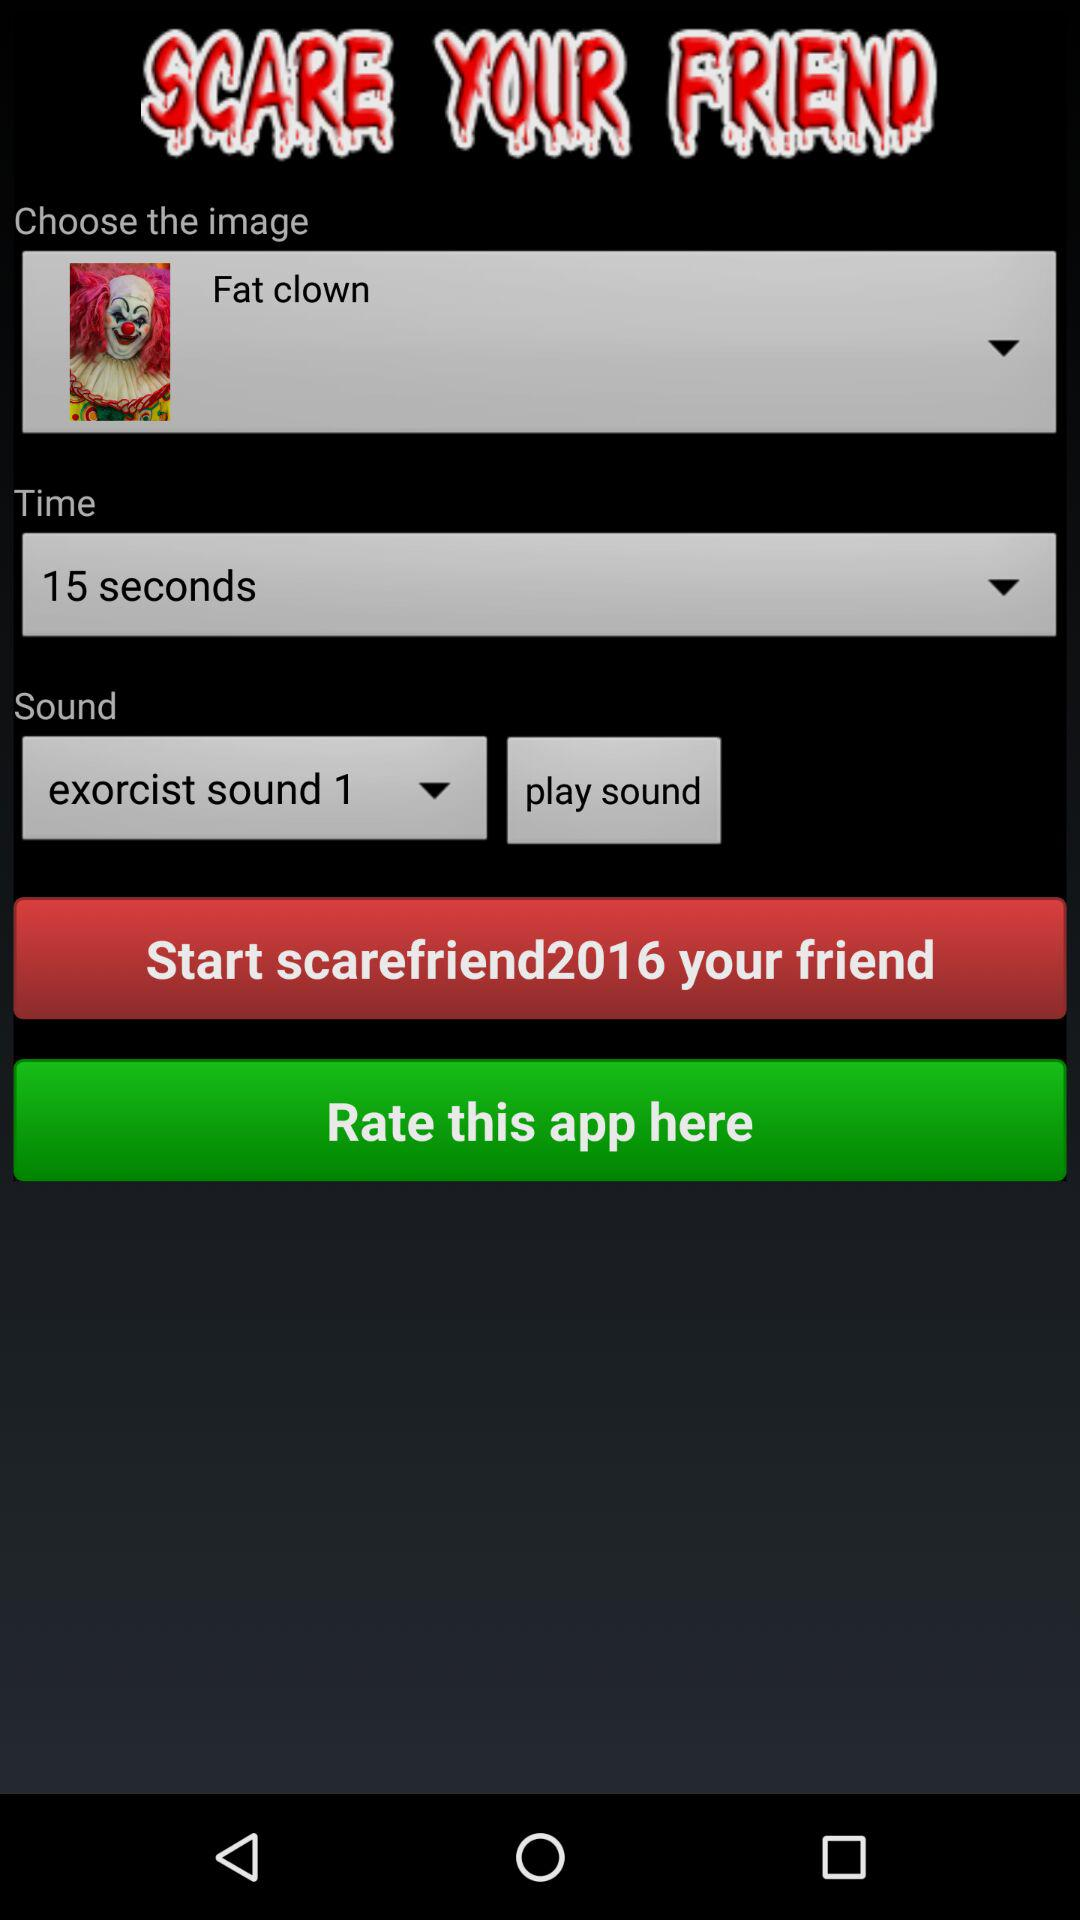How many more seconds are there in the time of 30 seconds than in the time of 15 seconds?
Answer the question using a single word or phrase. 15 